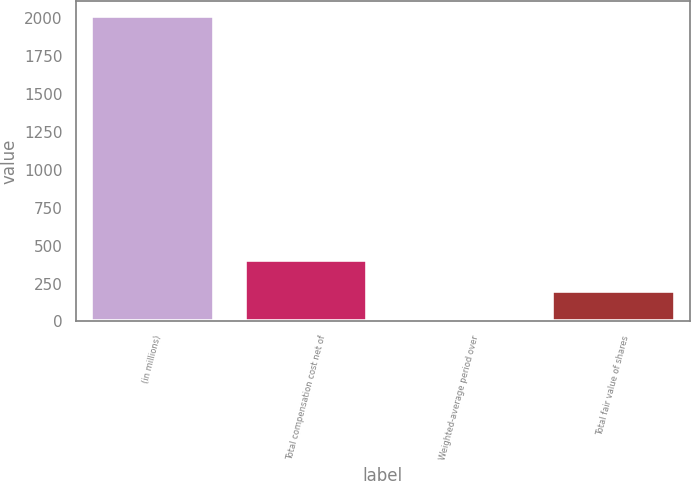<chart> <loc_0><loc_0><loc_500><loc_500><bar_chart><fcel>(in millions)<fcel>Total compensation cost net of<fcel>Weighted-average period over<fcel>Total fair value of shares<nl><fcel>2016<fcel>404.8<fcel>2<fcel>203.4<nl></chart> 